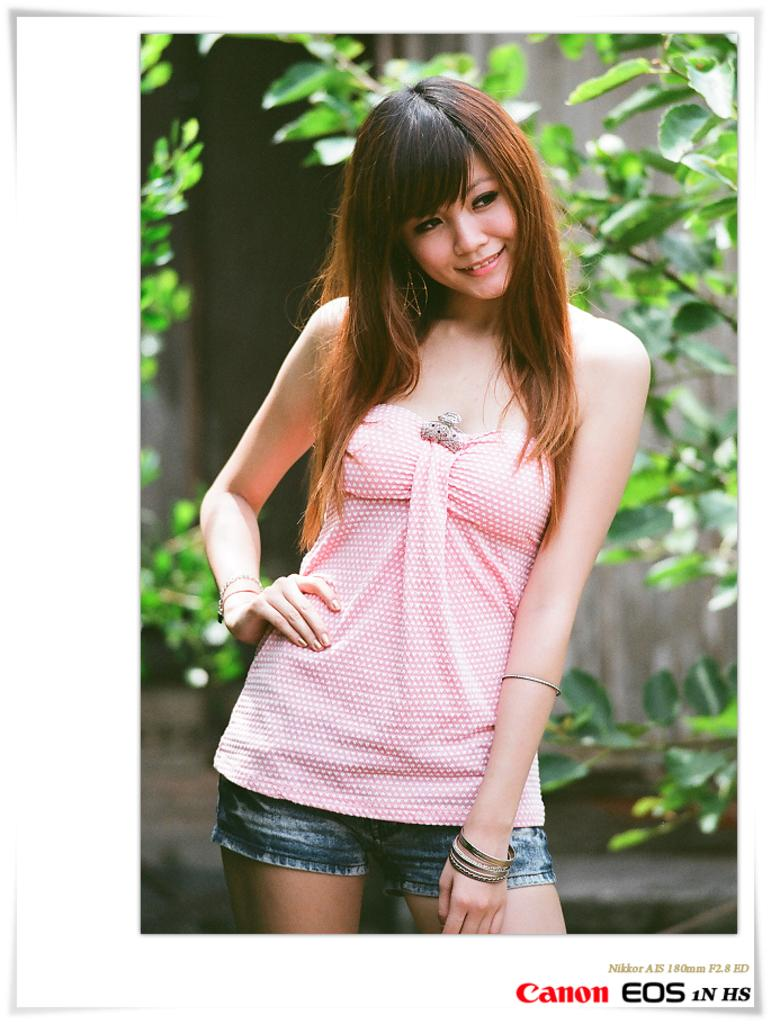What is the main subject of the image? There is a woman in the image. What is the woman doing in the image? The woman is standing and smiling. What can be seen in the background of the image? There are trees and a wall in the background of the image. Is there any text present in the image? Yes, there is some text in the bottom right corner of the image. How much tax is the woman paying in the image? There is no information about taxes in the image; it only features a woman standing and smiling, with trees and a wall in the background, and some text in the bottom right corner. How many sisters does the woman have in the image? There is no information about the woman's family or siblings in the image. 